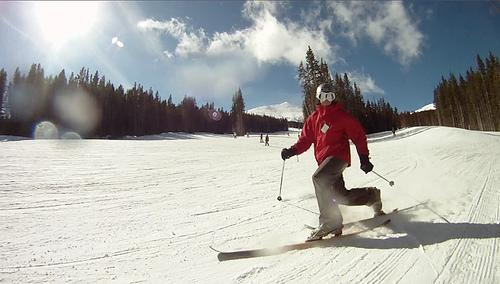What is causing the glare in the image? Please explain your reasoning. sun. The glare in the picture is most visible on the right side.  if you look at the far right top corner, there is part of the sun visible.  this is mostly source of glare. 